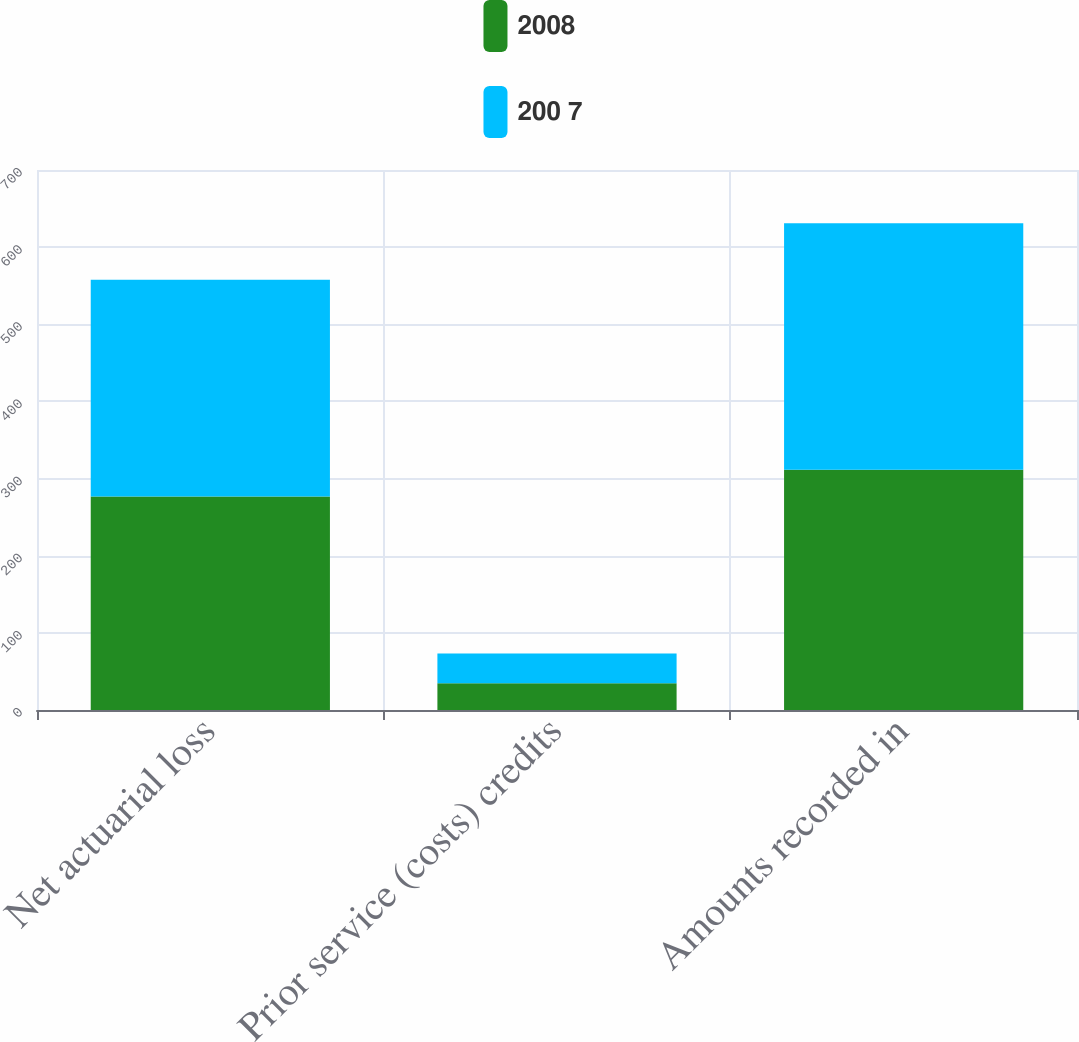<chart> <loc_0><loc_0><loc_500><loc_500><stacked_bar_chart><ecel><fcel>Net actuarial loss<fcel>Prior service (costs) credits<fcel>Amounts recorded in<nl><fcel>2008<fcel>276.8<fcel>34.7<fcel>311.5<nl><fcel>200 7<fcel>280.9<fcel>38.5<fcel>319.4<nl></chart> 